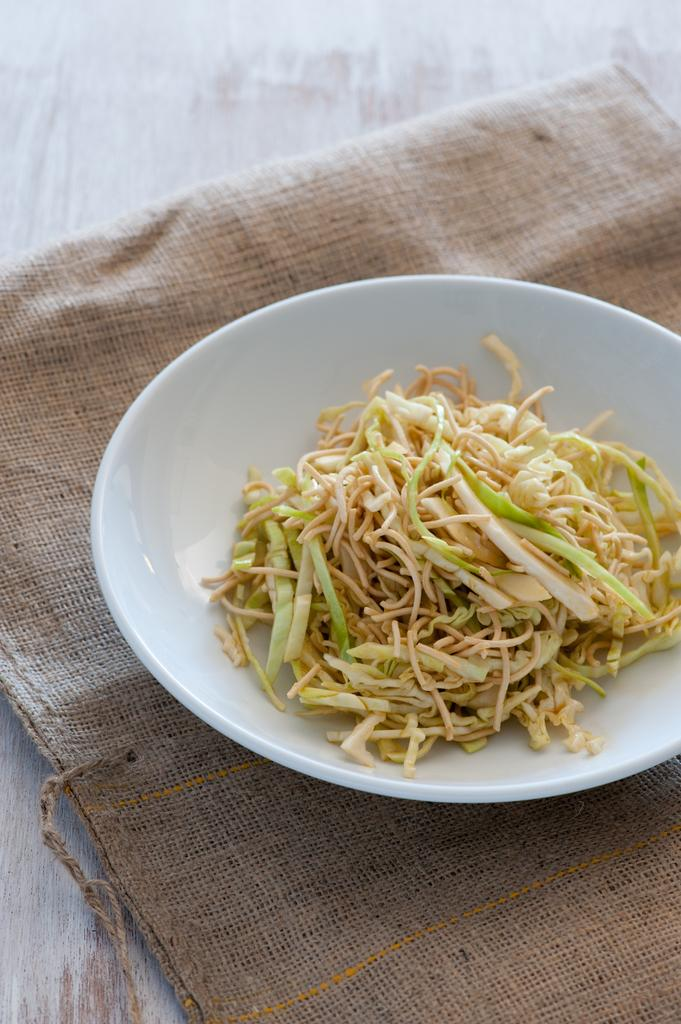What is on the plate that is visible in the image? There is a food item on a plate in the image. What is the plate resting on? The plate is placed on a cloth. Where is the cloth located? The cloth is on a table. Is the food item sinking in quicksand in the image? There is no quicksand present in the image, so the food item is not sinking in it. 